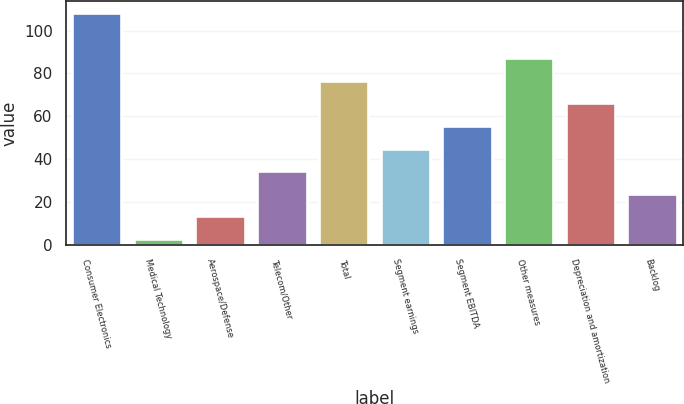Convert chart to OTSL. <chart><loc_0><loc_0><loc_500><loc_500><bar_chart><fcel>Consumer Electronics<fcel>Medical Technology<fcel>Aerospace/Defense<fcel>Telecom/Other<fcel>Total<fcel>Segment earnings<fcel>Segment EBITDA<fcel>Other measures<fcel>Depreciation and amortization<fcel>Backlog<nl><fcel>108.3<fcel>2.7<fcel>13.26<fcel>34.38<fcel>76.62<fcel>44.94<fcel>55.5<fcel>87.18<fcel>66.06<fcel>23.82<nl></chart> 